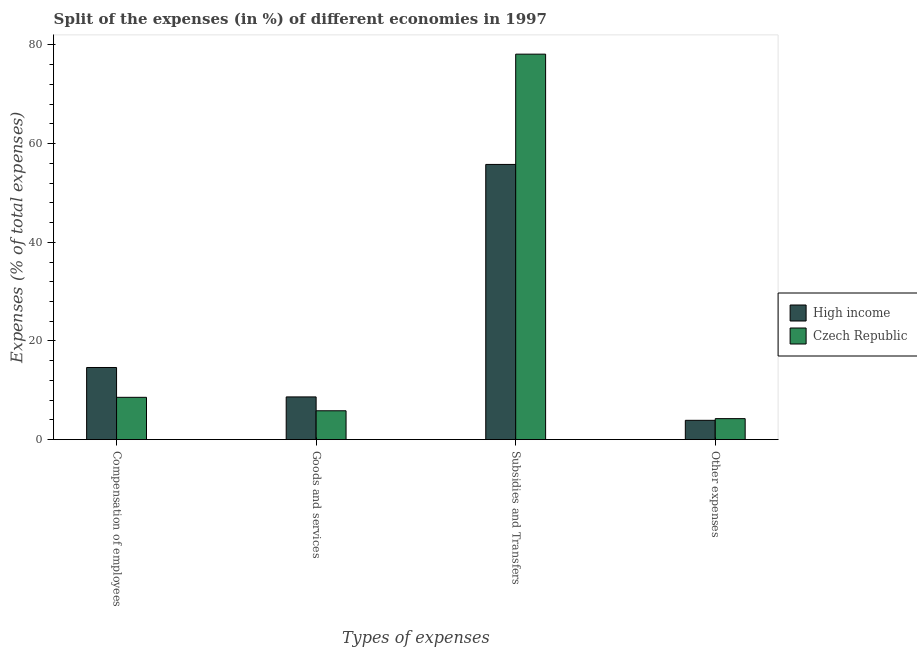How many groups of bars are there?
Make the answer very short. 4. Are the number of bars per tick equal to the number of legend labels?
Keep it short and to the point. Yes. Are the number of bars on each tick of the X-axis equal?
Your answer should be compact. Yes. How many bars are there on the 3rd tick from the left?
Ensure brevity in your answer.  2. What is the label of the 4th group of bars from the left?
Make the answer very short. Other expenses. What is the percentage of amount spent on other expenses in Czech Republic?
Make the answer very short. 4.25. Across all countries, what is the maximum percentage of amount spent on subsidies?
Offer a very short reply. 78.14. Across all countries, what is the minimum percentage of amount spent on goods and services?
Offer a terse response. 5.84. In which country was the percentage of amount spent on subsidies maximum?
Make the answer very short. Czech Republic. In which country was the percentage of amount spent on goods and services minimum?
Your response must be concise. Czech Republic. What is the total percentage of amount spent on goods and services in the graph?
Make the answer very short. 14.5. What is the difference between the percentage of amount spent on subsidies in Czech Republic and that in High income?
Offer a very short reply. 22.35. What is the difference between the percentage of amount spent on other expenses in Czech Republic and the percentage of amount spent on compensation of employees in High income?
Make the answer very short. -10.37. What is the average percentage of amount spent on other expenses per country?
Ensure brevity in your answer.  4.08. What is the difference between the percentage of amount spent on goods and services and percentage of amount spent on subsidies in Czech Republic?
Your response must be concise. -72.29. In how many countries, is the percentage of amount spent on compensation of employees greater than 72 %?
Offer a very short reply. 0. What is the ratio of the percentage of amount spent on compensation of employees in Czech Republic to that in High income?
Give a very brief answer. 0.59. Is the percentage of amount spent on subsidies in Czech Republic less than that in High income?
Your answer should be very brief. No. Is the difference between the percentage of amount spent on subsidies in Czech Republic and High income greater than the difference between the percentage of amount spent on compensation of employees in Czech Republic and High income?
Ensure brevity in your answer.  Yes. What is the difference between the highest and the second highest percentage of amount spent on subsidies?
Make the answer very short. 22.35. What is the difference between the highest and the lowest percentage of amount spent on subsidies?
Offer a very short reply. 22.35. Is the sum of the percentage of amount spent on compensation of employees in Czech Republic and High income greater than the maximum percentage of amount spent on subsidies across all countries?
Give a very brief answer. No. What does the 2nd bar from the left in Subsidies and Transfers represents?
Offer a very short reply. Czech Republic. What does the 2nd bar from the right in Compensation of employees represents?
Your answer should be compact. High income. Are all the bars in the graph horizontal?
Give a very brief answer. No. What is the difference between two consecutive major ticks on the Y-axis?
Make the answer very short. 20. Are the values on the major ticks of Y-axis written in scientific E-notation?
Make the answer very short. No. Does the graph contain any zero values?
Give a very brief answer. No. Does the graph contain grids?
Keep it short and to the point. No. Where does the legend appear in the graph?
Provide a short and direct response. Center right. How many legend labels are there?
Offer a very short reply. 2. How are the legend labels stacked?
Your response must be concise. Vertical. What is the title of the graph?
Keep it short and to the point. Split of the expenses (in %) of different economies in 1997. What is the label or title of the X-axis?
Provide a succinct answer. Types of expenses. What is the label or title of the Y-axis?
Provide a short and direct response. Expenses (% of total expenses). What is the Expenses (% of total expenses) of High income in Compensation of employees?
Your response must be concise. 14.62. What is the Expenses (% of total expenses) in Czech Republic in Compensation of employees?
Offer a terse response. 8.57. What is the Expenses (% of total expenses) in High income in Goods and services?
Your answer should be very brief. 8.65. What is the Expenses (% of total expenses) of Czech Republic in Goods and services?
Ensure brevity in your answer.  5.84. What is the Expenses (% of total expenses) of High income in Subsidies and Transfers?
Offer a very short reply. 55.78. What is the Expenses (% of total expenses) in Czech Republic in Subsidies and Transfers?
Your answer should be very brief. 78.14. What is the Expenses (% of total expenses) in High income in Other expenses?
Offer a very short reply. 3.91. What is the Expenses (% of total expenses) in Czech Republic in Other expenses?
Provide a short and direct response. 4.25. Across all Types of expenses, what is the maximum Expenses (% of total expenses) of High income?
Offer a terse response. 55.78. Across all Types of expenses, what is the maximum Expenses (% of total expenses) of Czech Republic?
Your answer should be very brief. 78.14. Across all Types of expenses, what is the minimum Expenses (% of total expenses) in High income?
Provide a succinct answer. 3.91. Across all Types of expenses, what is the minimum Expenses (% of total expenses) of Czech Republic?
Your answer should be very brief. 4.25. What is the total Expenses (% of total expenses) of High income in the graph?
Your answer should be very brief. 82.96. What is the total Expenses (% of total expenses) in Czech Republic in the graph?
Provide a succinct answer. 96.81. What is the difference between the Expenses (% of total expenses) of High income in Compensation of employees and that in Goods and services?
Your answer should be very brief. 5.96. What is the difference between the Expenses (% of total expenses) in Czech Republic in Compensation of employees and that in Goods and services?
Ensure brevity in your answer.  2.73. What is the difference between the Expenses (% of total expenses) of High income in Compensation of employees and that in Subsidies and Transfers?
Make the answer very short. -41.17. What is the difference between the Expenses (% of total expenses) of Czech Republic in Compensation of employees and that in Subsidies and Transfers?
Provide a short and direct response. -69.56. What is the difference between the Expenses (% of total expenses) of High income in Compensation of employees and that in Other expenses?
Ensure brevity in your answer.  10.71. What is the difference between the Expenses (% of total expenses) of Czech Republic in Compensation of employees and that in Other expenses?
Give a very brief answer. 4.32. What is the difference between the Expenses (% of total expenses) in High income in Goods and services and that in Subsidies and Transfers?
Your answer should be compact. -47.13. What is the difference between the Expenses (% of total expenses) of Czech Republic in Goods and services and that in Subsidies and Transfers?
Your response must be concise. -72.29. What is the difference between the Expenses (% of total expenses) in High income in Goods and services and that in Other expenses?
Make the answer very short. 4.75. What is the difference between the Expenses (% of total expenses) of Czech Republic in Goods and services and that in Other expenses?
Give a very brief answer. 1.59. What is the difference between the Expenses (% of total expenses) of High income in Subsidies and Transfers and that in Other expenses?
Your answer should be compact. 51.87. What is the difference between the Expenses (% of total expenses) in Czech Republic in Subsidies and Transfers and that in Other expenses?
Ensure brevity in your answer.  73.88. What is the difference between the Expenses (% of total expenses) of High income in Compensation of employees and the Expenses (% of total expenses) of Czech Republic in Goods and services?
Offer a terse response. 8.77. What is the difference between the Expenses (% of total expenses) of High income in Compensation of employees and the Expenses (% of total expenses) of Czech Republic in Subsidies and Transfers?
Provide a short and direct response. -63.52. What is the difference between the Expenses (% of total expenses) in High income in Compensation of employees and the Expenses (% of total expenses) in Czech Republic in Other expenses?
Give a very brief answer. 10.37. What is the difference between the Expenses (% of total expenses) in High income in Goods and services and the Expenses (% of total expenses) in Czech Republic in Subsidies and Transfers?
Ensure brevity in your answer.  -69.48. What is the difference between the Expenses (% of total expenses) of High income in Goods and services and the Expenses (% of total expenses) of Czech Republic in Other expenses?
Ensure brevity in your answer.  4.4. What is the difference between the Expenses (% of total expenses) in High income in Subsidies and Transfers and the Expenses (% of total expenses) in Czech Republic in Other expenses?
Make the answer very short. 51.53. What is the average Expenses (% of total expenses) in High income per Types of expenses?
Your answer should be compact. 20.74. What is the average Expenses (% of total expenses) of Czech Republic per Types of expenses?
Ensure brevity in your answer.  24.2. What is the difference between the Expenses (% of total expenses) of High income and Expenses (% of total expenses) of Czech Republic in Compensation of employees?
Offer a very short reply. 6.04. What is the difference between the Expenses (% of total expenses) of High income and Expenses (% of total expenses) of Czech Republic in Goods and services?
Make the answer very short. 2.81. What is the difference between the Expenses (% of total expenses) of High income and Expenses (% of total expenses) of Czech Republic in Subsidies and Transfers?
Your answer should be very brief. -22.35. What is the difference between the Expenses (% of total expenses) in High income and Expenses (% of total expenses) in Czech Republic in Other expenses?
Offer a terse response. -0.34. What is the ratio of the Expenses (% of total expenses) in High income in Compensation of employees to that in Goods and services?
Your answer should be compact. 1.69. What is the ratio of the Expenses (% of total expenses) in Czech Republic in Compensation of employees to that in Goods and services?
Offer a terse response. 1.47. What is the ratio of the Expenses (% of total expenses) of High income in Compensation of employees to that in Subsidies and Transfers?
Give a very brief answer. 0.26. What is the ratio of the Expenses (% of total expenses) of Czech Republic in Compensation of employees to that in Subsidies and Transfers?
Your answer should be very brief. 0.11. What is the ratio of the Expenses (% of total expenses) of High income in Compensation of employees to that in Other expenses?
Give a very brief answer. 3.74. What is the ratio of the Expenses (% of total expenses) of Czech Republic in Compensation of employees to that in Other expenses?
Ensure brevity in your answer.  2.02. What is the ratio of the Expenses (% of total expenses) of High income in Goods and services to that in Subsidies and Transfers?
Your answer should be compact. 0.16. What is the ratio of the Expenses (% of total expenses) of Czech Republic in Goods and services to that in Subsidies and Transfers?
Your answer should be very brief. 0.07. What is the ratio of the Expenses (% of total expenses) of High income in Goods and services to that in Other expenses?
Offer a very short reply. 2.21. What is the ratio of the Expenses (% of total expenses) of Czech Republic in Goods and services to that in Other expenses?
Offer a very short reply. 1.37. What is the ratio of the Expenses (% of total expenses) in High income in Subsidies and Transfers to that in Other expenses?
Make the answer very short. 14.27. What is the ratio of the Expenses (% of total expenses) of Czech Republic in Subsidies and Transfers to that in Other expenses?
Your response must be concise. 18.38. What is the difference between the highest and the second highest Expenses (% of total expenses) in High income?
Your answer should be very brief. 41.17. What is the difference between the highest and the second highest Expenses (% of total expenses) in Czech Republic?
Your response must be concise. 69.56. What is the difference between the highest and the lowest Expenses (% of total expenses) of High income?
Your answer should be compact. 51.87. What is the difference between the highest and the lowest Expenses (% of total expenses) of Czech Republic?
Your answer should be very brief. 73.88. 